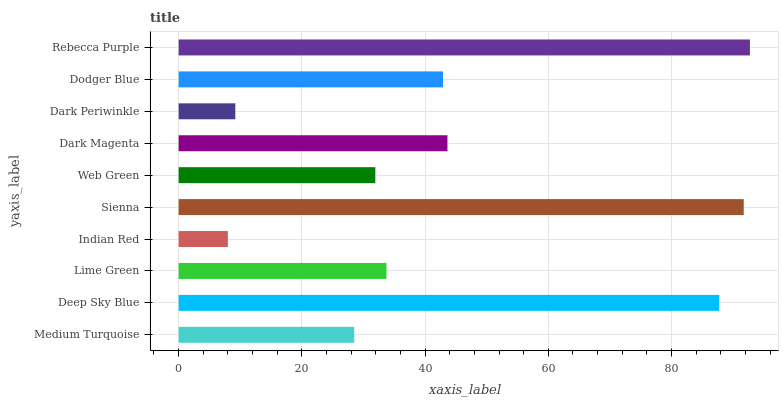Is Indian Red the minimum?
Answer yes or no. Yes. Is Rebecca Purple the maximum?
Answer yes or no. Yes. Is Deep Sky Blue the minimum?
Answer yes or no. No. Is Deep Sky Blue the maximum?
Answer yes or no. No. Is Deep Sky Blue greater than Medium Turquoise?
Answer yes or no. Yes. Is Medium Turquoise less than Deep Sky Blue?
Answer yes or no. Yes. Is Medium Turquoise greater than Deep Sky Blue?
Answer yes or no. No. Is Deep Sky Blue less than Medium Turquoise?
Answer yes or no. No. Is Dodger Blue the high median?
Answer yes or no. Yes. Is Lime Green the low median?
Answer yes or no. Yes. Is Lime Green the high median?
Answer yes or no. No. Is Dark Periwinkle the low median?
Answer yes or no. No. 